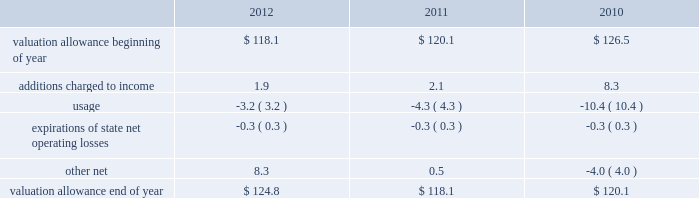Republic services , inc .
Notes to consolidated financial statements 2014 ( continued ) changes in the deferred tax valuation allowance for the years ended december 31 , 2012 , 2011 and 2010 are as follows: .
In assessing the realizability of deferred tax assets , management considers whether it is more likely than not that some portion or all of the deferred tax assets will not be realized after the initial recognition of the deferred tax asset .
We also provide valuation allowances , as needed , to offset portions of deferred tax assets due to uncertainty surrounding the future realization of such deferred tax assets .
We adjust the valuation allowance in the period management determines it is more likely than not that deferred tax assets will or will not be realized .
We have state net operating loss carryforwards with an estimated tax effect of $ 130.2 million available at december 31 , 2012 .
These state net operating loss carryforwards expire at various times between 2013 and 2032 .
We believe that it is more likely than not that the benefit from certain state net operating loss carryforwards will not be realized .
In recognition of this risk , at december 31 , 2012 , we have provided a valuation allowance of $ 113.5 million for certain state net operating loss carryforwards .
At december 31 , 2012 , we also have provided a valuation allowance of $ 11.3 million for certain other deferred tax assets .
Deferred income taxes have not been provided on the undistributed earnings of our puerto rican subsidiaries of approximately $ 40 million and $ 39 million as of december 31 , 2012 and 2011 , respectively , as such earnings are considered to be permanently invested in those subsidiaries .
If such earnings were to be remitted to us as dividends , we would incur approximately $ 14 million of federal income taxes .
We made income tax payments ( net of refunds received ) of approximately $ 185 million , $ 173 million and $ 418 million for 2012 , 2011 and 2010 , respectively .
Income taxes paid in 2012 and 2011 reflect the favorable tax depreciation provisions of the tax relief , unemployment insurance reauthorization , and job creation act of 2010 ( tax relief act ) that was signed into law in december 2010 .
The tax relief act included 100% ( 100 % ) bonus depreciation for property placed in service after september 8 , 2010 and through december 31 , 2011 ( and for certain long-term construction projects to be placed in service in 2012 ) and 50% ( 50 % ) bonus depreciation for property placed in service in 2012 ( and for certain long-term construction projects to be placed in service in 2013 ) .
Income taxes paid in 2010 includes $ 111 million related to the settlement of certain tax liabilities regarding bfi risk management companies .
We and our subsidiaries are subject to income tax in the u.s .
And puerto rico , as well as income tax in multiple state jurisdictions .
Our compliance with income tax rules and regulations is periodically audited by tax authorities .
These authorities may challenge the positions taken in our tax filings .
Thus , to provide for certain potential tax exposures , we maintain liabilities for uncertain tax positions for our estimate of the final outcome of the examinations. .
What was the average balance of the end of year valuation allowance from 2010-2012? 
Rationale: the average balance of the valuation allowance from 2010 to 2012 at year end was 121.6
Computations: (118.1 + 120.1)
Answer: 238.2. Republic services , inc .
Notes to consolidated financial statements 2014 ( continued ) changes in the deferred tax valuation allowance for the years ended december 31 , 2012 , 2011 and 2010 are as follows: .
In assessing the realizability of deferred tax assets , management considers whether it is more likely than not that some portion or all of the deferred tax assets will not be realized after the initial recognition of the deferred tax asset .
We also provide valuation allowances , as needed , to offset portions of deferred tax assets due to uncertainty surrounding the future realization of such deferred tax assets .
We adjust the valuation allowance in the period management determines it is more likely than not that deferred tax assets will or will not be realized .
We have state net operating loss carryforwards with an estimated tax effect of $ 130.2 million available at december 31 , 2012 .
These state net operating loss carryforwards expire at various times between 2013 and 2032 .
We believe that it is more likely than not that the benefit from certain state net operating loss carryforwards will not be realized .
In recognition of this risk , at december 31 , 2012 , we have provided a valuation allowance of $ 113.5 million for certain state net operating loss carryforwards .
At december 31 , 2012 , we also have provided a valuation allowance of $ 11.3 million for certain other deferred tax assets .
Deferred income taxes have not been provided on the undistributed earnings of our puerto rican subsidiaries of approximately $ 40 million and $ 39 million as of december 31 , 2012 and 2011 , respectively , as such earnings are considered to be permanently invested in those subsidiaries .
If such earnings were to be remitted to us as dividends , we would incur approximately $ 14 million of federal income taxes .
We made income tax payments ( net of refunds received ) of approximately $ 185 million , $ 173 million and $ 418 million for 2012 , 2011 and 2010 , respectively .
Income taxes paid in 2012 and 2011 reflect the favorable tax depreciation provisions of the tax relief , unemployment insurance reauthorization , and job creation act of 2010 ( tax relief act ) that was signed into law in december 2010 .
The tax relief act included 100% ( 100 % ) bonus depreciation for property placed in service after september 8 , 2010 and through december 31 , 2011 ( and for certain long-term construction projects to be placed in service in 2012 ) and 50% ( 50 % ) bonus depreciation for property placed in service in 2012 ( and for certain long-term construction projects to be placed in service in 2013 ) .
Income taxes paid in 2010 includes $ 111 million related to the settlement of certain tax liabilities regarding bfi risk management companies .
We and our subsidiaries are subject to income tax in the u.s .
And puerto rico , as well as income tax in multiple state jurisdictions .
Our compliance with income tax rules and regulations is periodically audited by tax authorities .
These authorities may challenge the positions taken in our tax filings .
Thus , to provide for certain potential tax exposures , we maintain liabilities for uncertain tax positions for our estimate of the final outcome of the examinations. .
What is the percent of the valuation allowance to the state net operating loss carry forwards at december 312012? 
Rationale: the valuation allowance is 87% of the of the state net operating loss carry forwards at december 312012
Computations: (113.5 / 130.2)
Answer: 0.87174. 